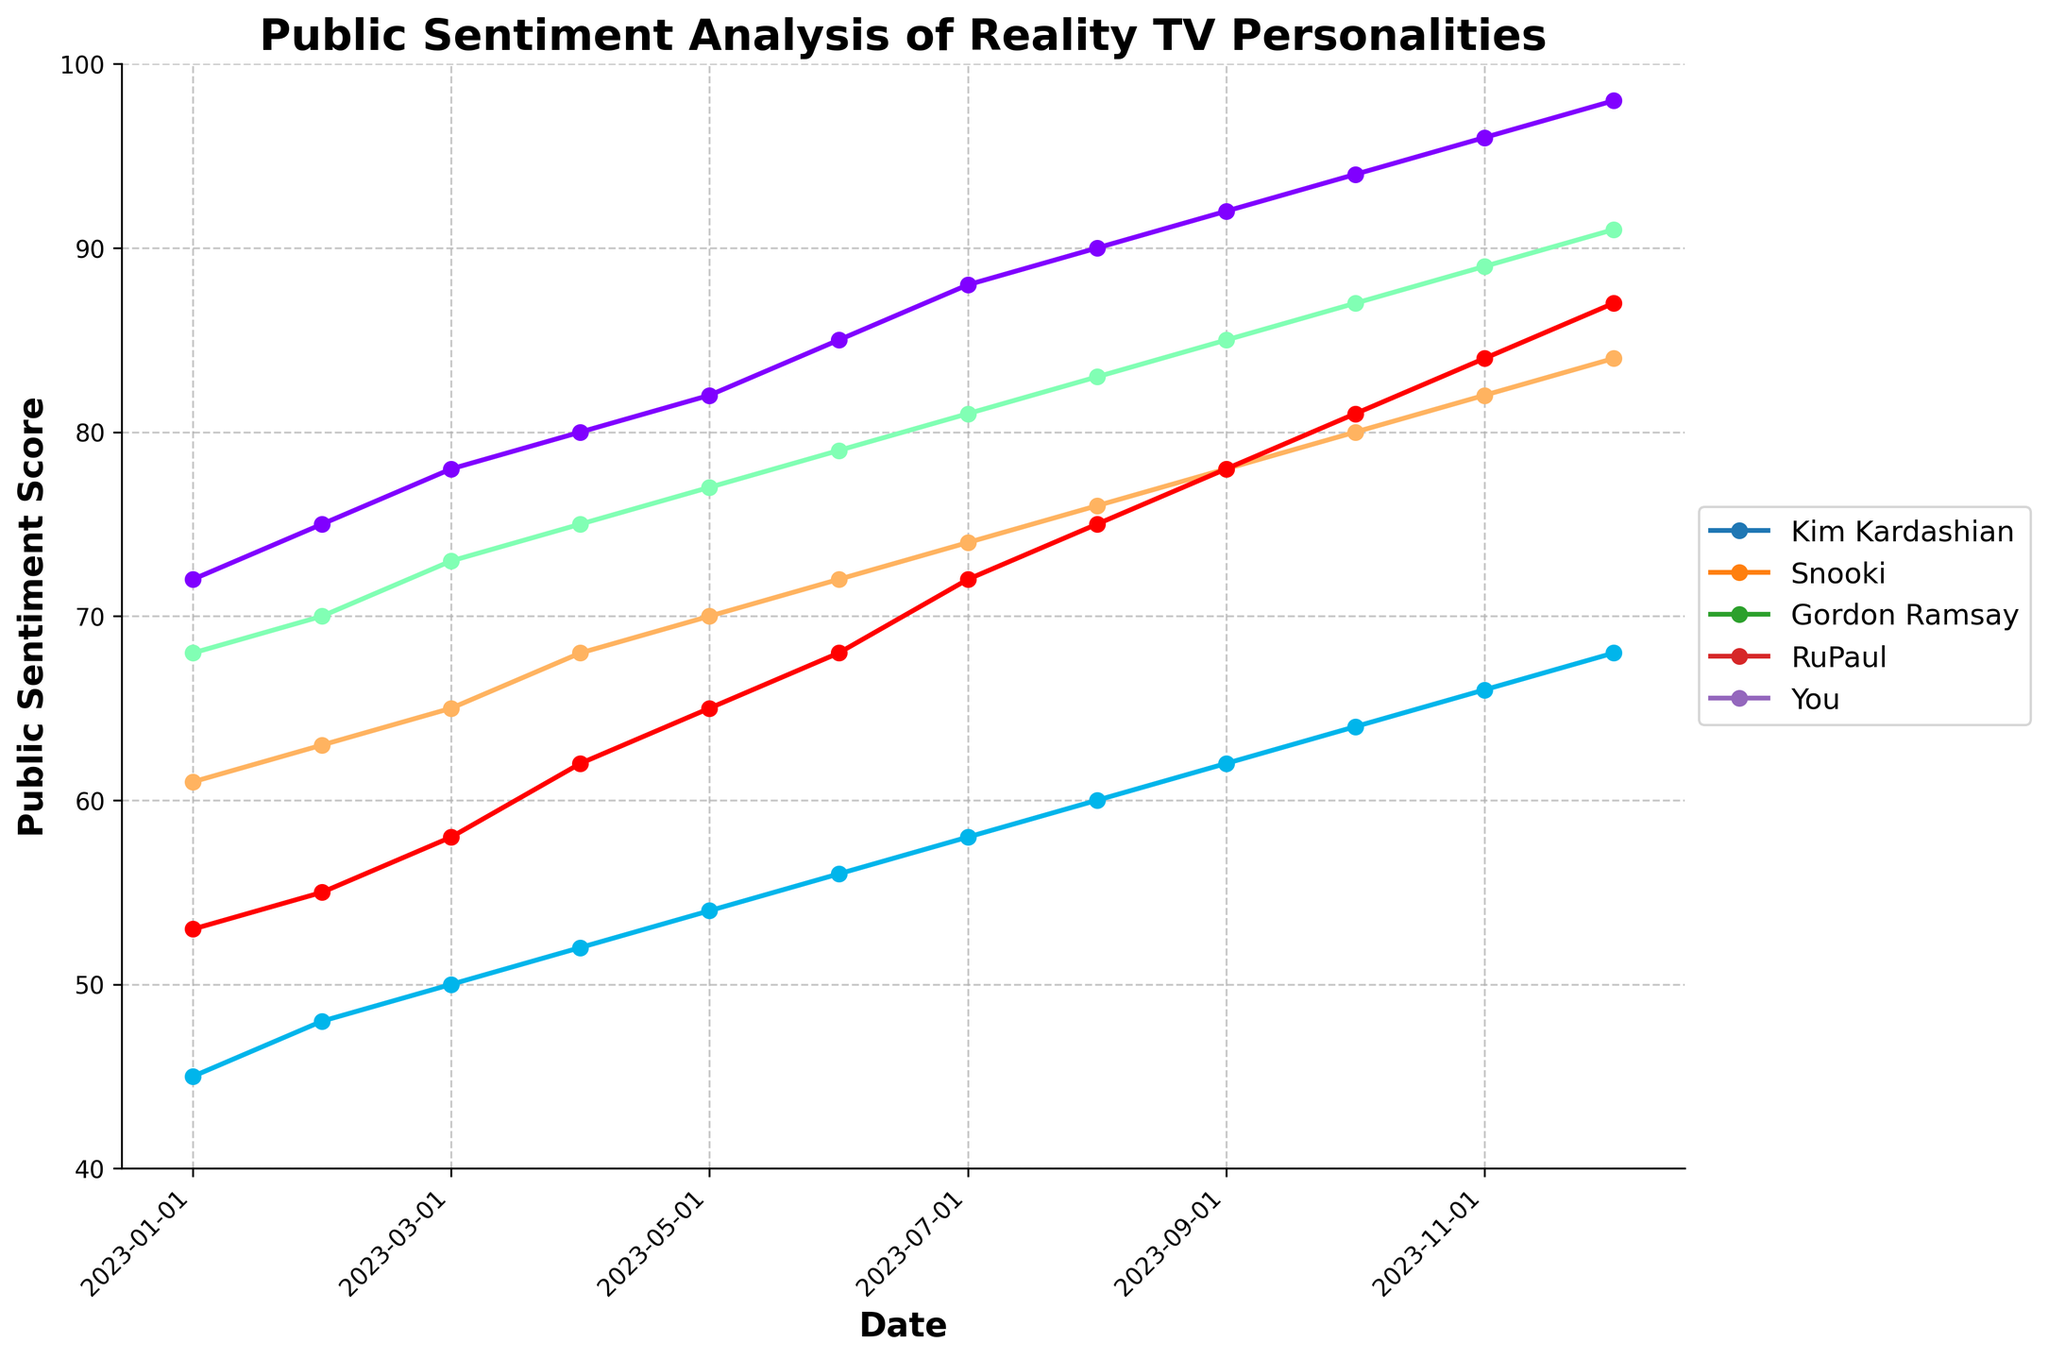Which personality has the highest public sentiment score in December 2023? To identify the personality with the highest sentiment score, look at the data points on the y-axis corresponding to "December 2023" and compare them. Kim Kardashian has the highest score of 98.
Answer: Kim Kardashian How does your public sentiment in January 2023 compare to Kim Kardashian's sentiment in the same month? Check the y-axis values for January 2023 for both "You" and "Kim Kardashian." Your sentiment is 53, while Kim Kardashian's sentiment is 72. Kim Kardashian's sentiment is higher by 19 points.
Answer: Kim Kardashian is higher by 19 points Which personality had the least growth in public sentiment from January to December 2023? Calculate the difference between the sentiment scores in January and December 2023 for each personality and compare them. The differences are: Kim Kardashian (26), Snooki (23), Gordon Ramsay (23), RuPaul (23), and You (34). Snooki, Gordon Ramsay, and RuPaul all have the smallest growth of 23 points.
Answer: Snooki, Gordon Ramsay, and RuPaul How much did your public sentiment score increase from June to December 2023? Look at the sentiment scores for "You" in June 2023 and December 2023. Subtract the June score (68) from the December score (87). The sentiment increased by 19 points.
Answer: 19 points Between which two months did Snooki's public sentiment see the greatest increase? Calculate the month-to-month changes for Snooki's sentiment. The monthly increases are: Feb-Jan (3), Mar-Feb (2), Apr-Mar (2), May-Apr (2), Jun-May (2), Jul-Jun (2), Aug-Jul (2), Sep-Aug (2), Oct-Sep (2), Nov-Oct (2), and Dec-Nov (2). The greatest increase is from January to February (3 points).
Answer: January to February Who had the highest sentiment score consistently up to June 2023? Compare the sentiment scores for all personalities up to June 2023. Kim Kardashian had the highest scores in all these months.
Answer: Kim Kardashian Which two personalities had the closest sentiment scores in December 2023? Look at the sentiment scores for all personalities in December 2023 and find the smallest difference. The closest scores are those of RuPaul (84) and You (87), with a difference of 3 points.
Answer: RuPaul and You What is the average public sentiment score for Gordon Ramsay across the entire year? Sum all the monthly scores for Gordon Ramsay and divide by the number of months (12). (68 + 70 + 73 + 75 + 77 + 79 + 81 + 83 + 85 + 87 + 89 + 91) / 12 = 78.
Answer: 78 What visual feature indicates the sentiment trend for all personalities? Examine the slopes and directions of the lines for each personality. All lines have an upward slope, indicating an increasing trend in public sentiment throughout the year.
Answer: Upward slope How do the growth rates of Gordon Ramsay and RuPaul from January to December 2023 compare? Calculate the difference between January and December 2023 for both. Gordon Ramsay's sentiment grows from 68 to 91 (23 points), and RuPaul's sentiment grows from 61 to 84 (23 points). Both have the same growth rate.
Answer: Same growth rate 